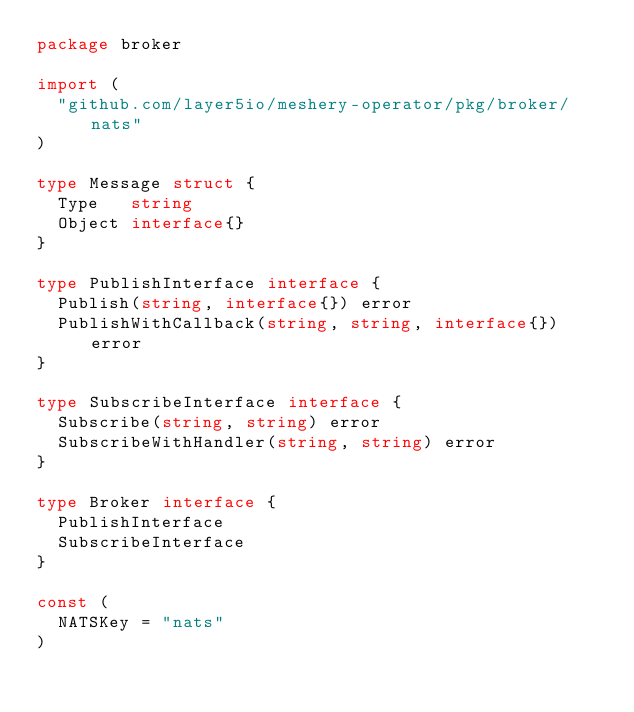<code> <loc_0><loc_0><loc_500><loc_500><_Go_>package broker

import (
	"github.com/layer5io/meshery-operator/pkg/broker/nats"
)

type Message struct {
	Type   string
	Object interface{}
}

type PublishInterface interface {
	Publish(string, interface{}) error
	PublishWithCallback(string, string, interface{}) error
}

type SubscribeInterface interface {
	Subscribe(string, string) error
	SubscribeWithHandler(string, string) error
}

type Broker interface {
	PublishInterface
	SubscribeInterface
}

const (
	NATSKey = "nats"
)
</code> 